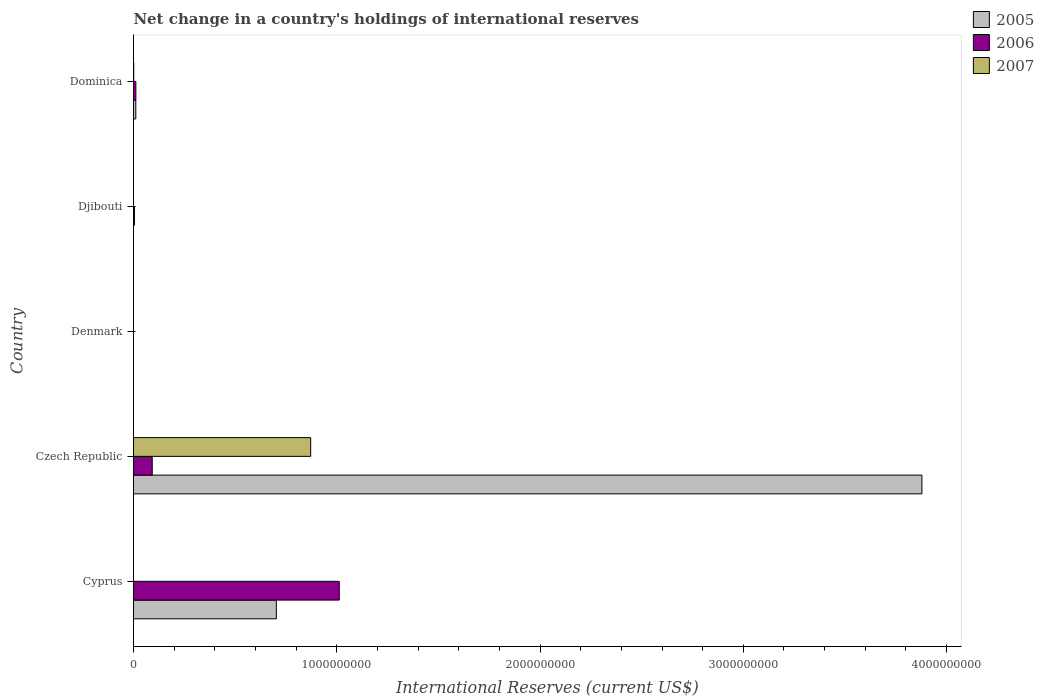How many different coloured bars are there?
Provide a short and direct response. 3. Are the number of bars per tick equal to the number of legend labels?
Offer a terse response. No. How many bars are there on the 2nd tick from the top?
Your response must be concise. 1. How many bars are there on the 4th tick from the bottom?
Make the answer very short. 1. What is the label of the 2nd group of bars from the top?
Your response must be concise. Djibouti. What is the international reserves in 2006 in Denmark?
Keep it short and to the point. 0. Across all countries, what is the maximum international reserves in 2006?
Your answer should be very brief. 1.01e+09. Across all countries, what is the minimum international reserves in 2007?
Keep it short and to the point. 0. In which country was the international reserves in 2005 maximum?
Keep it short and to the point. Czech Republic. What is the total international reserves in 2006 in the graph?
Offer a very short reply. 1.12e+09. What is the difference between the international reserves in 2005 in Cyprus and that in Dominica?
Make the answer very short. 6.91e+08. What is the average international reserves in 2007 per country?
Your response must be concise. 1.75e+08. What is the difference between the international reserves in 2007 and international reserves in 2006 in Dominica?
Your response must be concise. -1.04e+07. What is the ratio of the international reserves in 2007 in Czech Republic to that in Dominica?
Keep it short and to the point. 748.74. Is the international reserves in 2006 in Czech Republic less than that in Djibouti?
Ensure brevity in your answer.  No. Is the difference between the international reserves in 2007 in Czech Republic and Dominica greater than the difference between the international reserves in 2006 in Czech Republic and Dominica?
Provide a short and direct response. Yes. What is the difference between the highest and the second highest international reserves in 2006?
Ensure brevity in your answer.  9.20e+08. What is the difference between the highest and the lowest international reserves in 2006?
Offer a terse response. 1.01e+09. Is the sum of the international reserves in 2006 in Czech Republic and Dominica greater than the maximum international reserves in 2007 across all countries?
Your answer should be very brief. No. Is it the case that in every country, the sum of the international reserves in 2007 and international reserves in 2006 is greater than the international reserves in 2005?
Provide a succinct answer. No. How many bars are there?
Your answer should be compact. 9. Does the graph contain any zero values?
Make the answer very short. Yes. Does the graph contain grids?
Keep it short and to the point. No. Where does the legend appear in the graph?
Ensure brevity in your answer.  Top right. What is the title of the graph?
Provide a succinct answer. Net change in a country's holdings of international reserves. What is the label or title of the X-axis?
Offer a terse response. International Reserves (current US$). What is the label or title of the Y-axis?
Offer a very short reply. Country. What is the International Reserves (current US$) of 2005 in Cyprus?
Offer a terse response. 7.03e+08. What is the International Reserves (current US$) of 2006 in Cyprus?
Keep it short and to the point. 1.01e+09. What is the International Reserves (current US$) of 2005 in Czech Republic?
Your answer should be very brief. 3.88e+09. What is the International Reserves (current US$) of 2006 in Czech Republic?
Provide a short and direct response. 9.21e+07. What is the International Reserves (current US$) in 2007 in Czech Republic?
Your answer should be compact. 8.72e+08. What is the International Reserves (current US$) in 2005 in Denmark?
Your answer should be compact. 0. What is the International Reserves (current US$) of 2007 in Denmark?
Make the answer very short. 0. What is the International Reserves (current US$) of 2006 in Djibouti?
Give a very brief answer. 4.65e+06. What is the International Reserves (current US$) in 2007 in Djibouti?
Keep it short and to the point. 0. What is the International Reserves (current US$) of 2005 in Dominica?
Offer a terse response. 1.12e+07. What is the International Reserves (current US$) of 2006 in Dominica?
Provide a short and direct response. 1.16e+07. What is the International Reserves (current US$) of 2007 in Dominica?
Make the answer very short. 1.16e+06. Across all countries, what is the maximum International Reserves (current US$) of 2005?
Provide a short and direct response. 3.88e+09. Across all countries, what is the maximum International Reserves (current US$) of 2006?
Offer a very short reply. 1.01e+09. Across all countries, what is the maximum International Reserves (current US$) in 2007?
Give a very brief answer. 8.72e+08. Across all countries, what is the minimum International Reserves (current US$) in 2007?
Your response must be concise. 0. What is the total International Reserves (current US$) of 2005 in the graph?
Your response must be concise. 4.59e+09. What is the total International Reserves (current US$) in 2006 in the graph?
Your response must be concise. 1.12e+09. What is the total International Reserves (current US$) in 2007 in the graph?
Give a very brief answer. 8.73e+08. What is the difference between the International Reserves (current US$) in 2005 in Cyprus and that in Czech Republic?
Your response must be concise. -3.18e+09. What is the difference between the International Reserves (current US$) of 2006 in Cyprus and that in Czech Republic?
Offer a very short reply. 9.20e+08. What is the difference between the International Reserves (current US$) in 2006 in Cyprus and that in Djibouti?
Offer a terse response. 1.01e+09. What is the difference between the International Reserves (current US$) of 2005 in Cyprus and that in Dominica?
Provide a succinct answer. 6.91e+08. What is the difference between the International Reserves (current US$) in 2006 in Cyprus and that in Dominica?
Your answer should be very brief. 1.00e+09. What is the difference between the International Reserves (current US$) in 2006 in Czech Republic and that in Djibouti?
Your answer should be very brief. 8.74e+07. What is the difference between the International Reserves (current US$) in 2005 in Czech Republic and that in Dominica?
Your answer should be very brief. 3.87e+09. What is the difference between the International Reserves (current US$) of 2006 in Czech Republic and that in Dominica?
Your answer should be very brief. 8.05e+07. What is the difference between the International Reserves (current US$) of 2007 in Czech Republic and that in Dominica?
Provide a short and direct response. 8.70e+08. What is the difference between the International Reserves (current US$) in 2006 in Djibouti and that in Dominica?
Offer a very short reply. -6.92e+06. What is the difference between the International Reserves (current US$) of 2005 in Cyprus and the International Reserves (current US$) of 2006 in Czech Republic?
Offer a terse response. 6.11e+08. What is the difference between the International Reserves (current US$) of 2005 in Cyprus and the International Reserves (current US$) of 2007 in Czech Republic?
Provide a succinct answer. -1.69e+08. What is the difference between the International Reserves (current US$) in 2006 in Cyprus and the International Reserves (current US$) in 2007 in Czech Republic?
Offer a very short reply. 1.41e+08. What is the difference between the International Reserves (current US$) of 2005 in Cyprus and the International Reserves (current US$) of 2006 in Djibouti?
Provide a short and direct response. 6.98e+08. What is the difference between the International Reserves (current US$) in 2005 in Cyprus and the International Reserves (current US$) in 2006 in Dominica?
Provide a short and direct response. 6.91e+08. What is the difference between the International Reserves (current US$) in 2005 in Cyprus and the International Reserves (current US$) in 2007 in Dominica?
Your answer should be very brief. 7.02e+08. What is the difference between the International Reserves (current US$) of 2006 in Cyprus and the International Reserves (current US$) of 2007 in Dominica?
Your response must be concise. 1.01e+09. What is the difference between the International Reserves (current US$) of 2005 in Czech Republic and the International Reserves (current US$) of 2006 in Djibouti?
Provide a succinct answer. 3.87e+09. What is the difference between the International Reserves (current US$) of 2005 in Czech Republic and the International Reserves (current US$) of 2006 in Dominica?
Your answer should be compact. 3.87e+09. What is the difference between the International Reserves (current US$) in 2005 in Czech Republic and the International Reserves (current US$) in 2007 in Dominica?
Offer a terse response. 3.88e+09. What is the difference between the International Reserves (current US$) of 2006 in Czech Republic and the International Reserves (current US$) of 2007 in Dominica?
Provide a short and direct response. 9.09e+07. What is the difference between the International Reserves (current US$) in 2006 in Djibouti and the International Reserves (current US$) in 2007 in Dominica?
Provide a short and direct response. 3.49e+06. What is the average International Reserves (current US$) of 2005 per country?
Offer a very short reply. 9.19e+08. What is the average International Reserves (current US$) in 2006 per country?
Your answer should be very brief. 2.24e+08. What is the average International Reserves (current US$) of 2007 per country?
Make the answer very short. 1.75e+08. What is the difference between the International Reserves (current US$) in 2005 and International Reserves (current US$) in 2006 in Cyprus?
Your answer should be compact. -3.10e+08. What is the difference between the International Reserves (current US$) of 2005 and International Reserves (current US$) of 2006 in Czech Republic?
Your answer should be compact. 3.79e+09. What is the difference between the International Reserves (current US$) in 2005 and International Reserves (current US$) in 2007 in Czech Republic?
Provide a succinct answer. 3.01e+09. What is the difference between the International Reserves (current US$) in 2006 and International Reserves (current US$) in 2007 in Czech Republic?
Your answer should be compact. -7.80e+08. What is the difference between the International Reserves (current US$) of 2005 and International Reserves (current US$) of 2006 in Dominica?
Make the answer very short. -3.41e+05. What is the difference between the International Reserves (current US$) in 2005 and International Reserves (current US$) in 2007 in Dominica?
Offer a very short reply. 1.01e+07. What is the difference between the International Reserves (current US$) in 2006 and International Reserves (current US$) in 2007 in Dominica?
Offer a terse response. 1.04e+07. What is the ratio of the International Reserves (current US$) in 2005 in Cyprus to that in Czech Republic?
Your answer should be very brief. 0.18. What is the ratio of the International Reserves (current US$) in 2006 in Cyprus to that in Czech Republic?
Your response must be concise. 10.99. What is the ratio of the International Reserves (current US$) of 2006 in Cyprus to that in Djibouti?
Offer a terse response. 217.65. What is the ratio of the International Reserves (current US$) in 2005 in Cyprus to that in Dominica?
Offer a terse response. 62.59. What is the ratio of the International Reserves (current US$) in 2006 in Cyprus to that in Dominica?
Your answer should be very brief. 87.5. What is the ratio of the International Reserves (current US$) in 2006 in Czech Republic to that in Djibouti?
Ensure brevity in your answer.  19.8. What is the ratio of the International Reserves (current US$) of 2005 in Czech Republic to that in Dominica?
Give a very brief answer. 345.45. What is the ratio of the International Reserves (current US$) of 2006 in Czech Republic to that in Dominica?
Offer a terse response. 7.96. What is the ratio of the International Reserves (current US$) of 2007 in Czech Republic to that in Dominica?
Provide a succinct answer. 748.74. What is the ratio of the International Reserves (current US$) of 2006 in Djibouti to that in Dominica?
Offer a very short reply. 0.4. What is the difference between the highest and the second highest International Reserves (current US$) in 2005?
Your answer should be compact. 3.18e+09. What is the difference between the highest and the second highest International Reserves (current US$) of 2006?
Provide a succinct answer. 9.20e+08. What is the difference between the highest and the lowest International Reserves (current US$) in 2005?
Make the answer very short. 3.88e+09. What is the difference between the highest and the lowest International Reserves (current US$) of 2006?
Provide a succinct answer. 1.01e+09. What is the difference between the highest and the lowest International Reserves (current US$) in 2007?
Make the answer very short. 8.72e+08. 